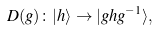<formula> <loc_0><loc_0><loc_500><loc_500>D ( g ) \colon | h \rangle \to | g h g ^ { - 1 } \rangle ,</formula> 